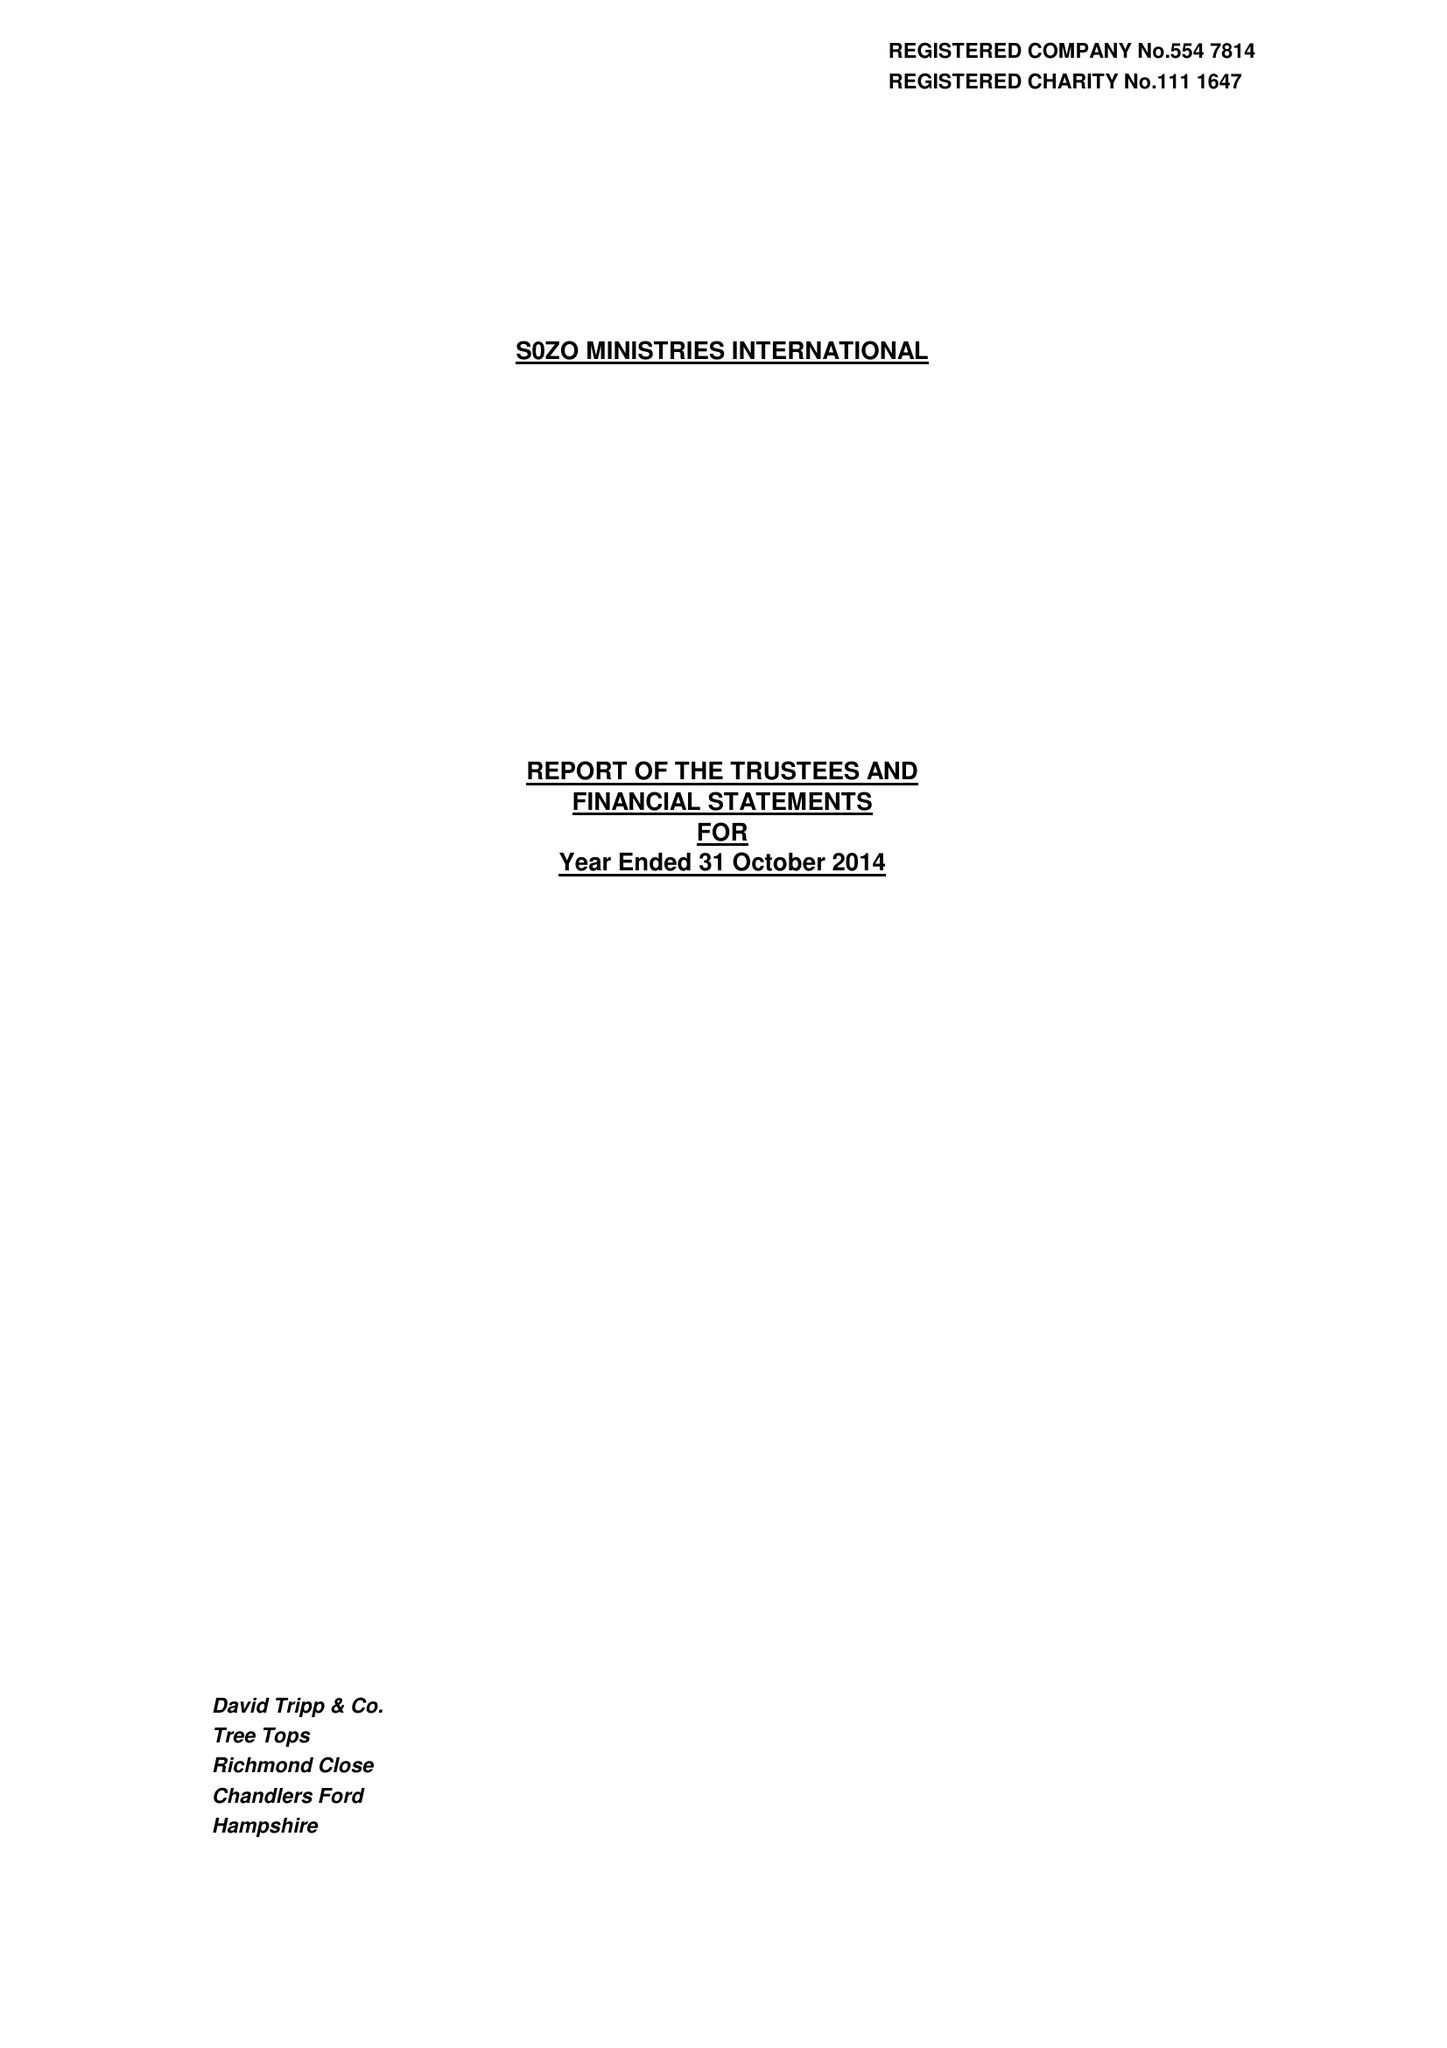What is the value for the address__postcode?
Answer the question using a single word or phrase. SO51 0GF 